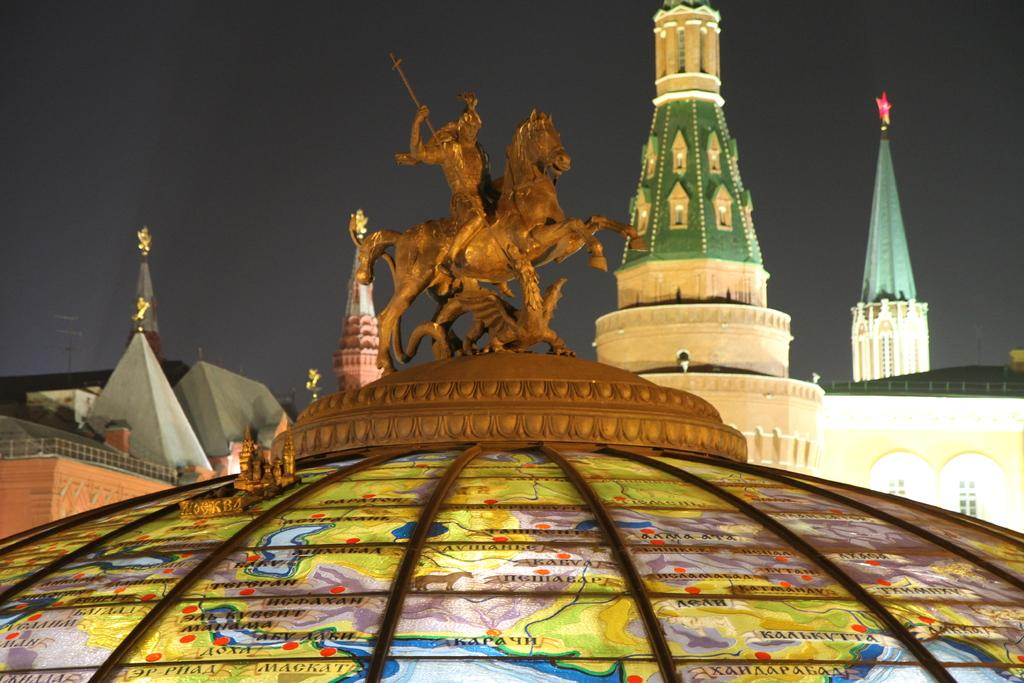What is the main subject in the foreground of the picture? There is a sculpture on the dome of a building in the foreground of the picture. What can be seen in the middle of the picture? There are buildings in the middle of the picture. What is visible at the top of the picture? The sky is visible at the top of the picture. How much powder is needed to cover the distance between the buildings in the image? There is no mention of powder or distance between buildings in the image, so this question cannot be answered definitively. 